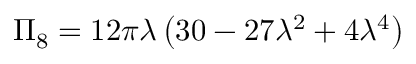<formula> <loc_0><loc_0><loc_500><loc_500>\Pi _ { 8 } = 1 2 \pi \lambda \left ( 3 0 - 2 7 \lambda ^ { 2 } + 4 \lambda ^ { 4 } \right )</formula> 